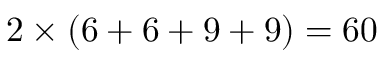Convert formula to latex. <formula><loc_0><loc_0><loc_500><loc_500>2 \times ( 6 + 6 + 9 + 9 ) = 6 0</formula> 